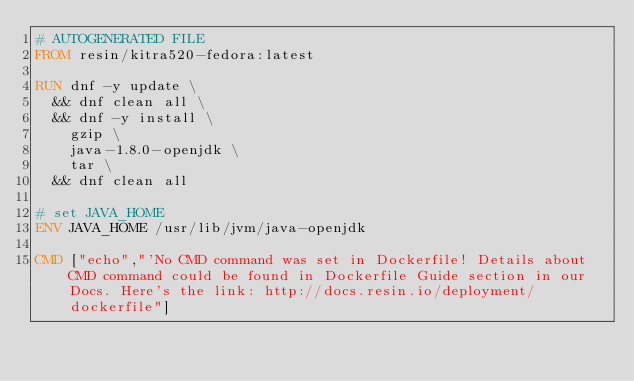Convert code to text. <code><loc_0><loc_0><loc_500><loc_500><_Dockerfile_># AUTOGENERATED FILE
FROM resin/kitra520-fedora:latest

RUN dnf -y update \
	&& dnf clean all \
	&& dnf -y install \
		gzip \
		java-1.8.0-openjdk \
		tar \
	&& dnf clean all

# set JAVA_HOME
ENV JAVA_HOME /usr/lib/jvm/java-openjdk

CMD ["echo","'No CMD command was set in Dockerfile! Details about CMD command could be found in Dockerfile Guide section in our Docs. Here's the link: http://docs.resin.io/deployment/dockerfile"]</code> 